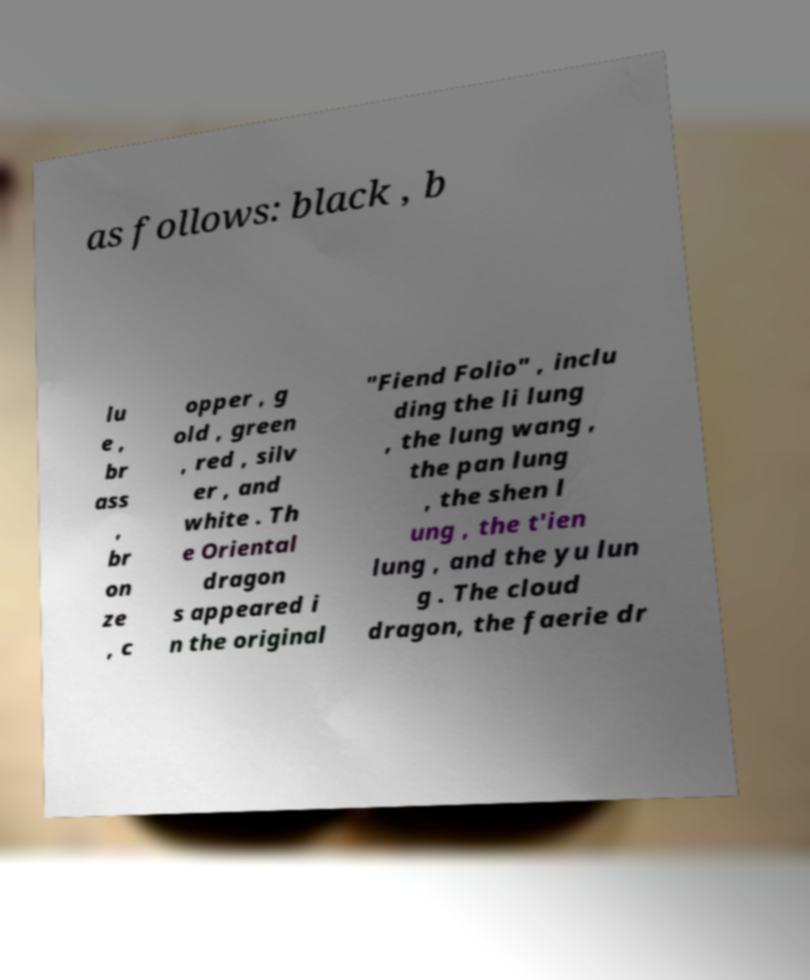For documentation purposes, I need the text within this image transcribed. Could you provide that? as follows: black , b lu e , br ass , br on ze , c opper , g old , green , red , silv er , and white . Th e Oriental dragon s appeared i n the original "Fiend Folio" , inclu ding the li lung , the lung wang , the pan lung , the shen l ung , the t'ien lung , and the yu lun g . The cloud dragon, the faerie dr 